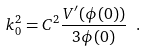<formula> <loc_0><loc_0><loc_500><loc_500>k _ { 0 } ^ { 2 } = C ^ { 2 } { \frac { V ^ { \prime } ( \phi ( 0 ) ) } { 3 \phi ( 0 ) } } \ .</formula> 